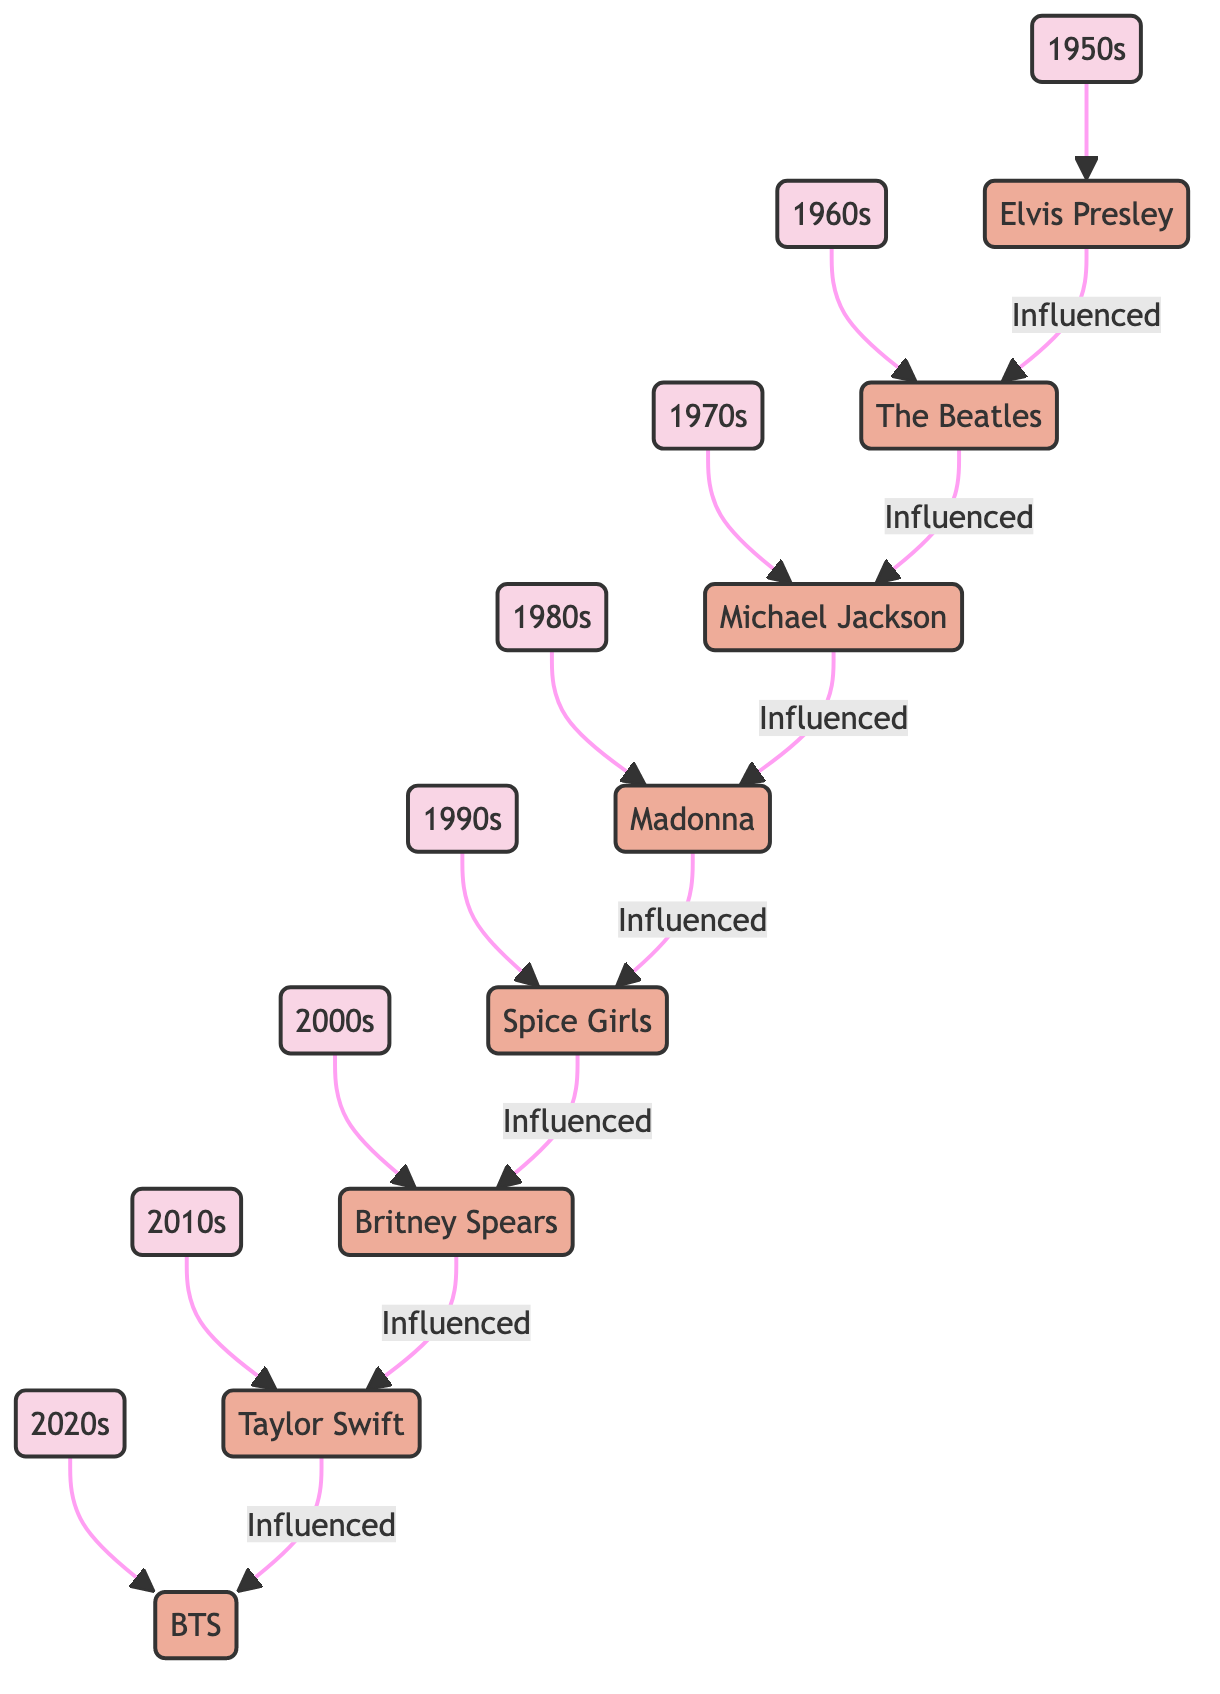What decade does Elvis Presley represent in the diagram? The node labeled "Elvis Presley" is connected to the node labeled "1950s." Hence, the decade he represents is the 1950s.
Answer: 1950s How many influential artists are listed in the diagram? The diagram contains eight artists, each connected to a specific era, all of whom are noted as "Influential Artist" in the connections.
Answer: 8 Which artist is directly influenced by Madonna? The edge labeled "Influenced" leads from the node "Madonna" to the node "Spice Girls," indicating that Spice Girls are directly influenced by Madonna.
Answer: Spice Girls What is the relationship between the 2010s and Taylor Swift in the diagram? The node "2010s" points to the node "Taylor Swift" labeled "Influential Artist," showing that Taylor Swift represents and is notable in the 2010s era of pop music.
Answer: Influential Artist Who influenced Taylor Swift according to the diagram? The edge labeled "Influenced" leads from the node "Taylor Swift" to the node "BTS," which indicates that BTS is the artist influenced by Taylor Swift.
Answer: BTS Which decade saw the emergence of boy bands and girl groups? The "1990s" node is explicitly described with the emergence of boy bands and girl groups, as reflected in its definition within the diagram.
Answer: 1990s How does Michael Jackson fit into the evolution of pop music as shown in the diagram? Michael Jackson is connected to the "1970s" era as a representative artist and also holds a directional connection as being influenced by "The Beatles," demonstrating his key role in this evolution sequence.
Answer: 1970s Which artist connects the 1980s to the 1990s? Madonna, who is connected to the 1980s as an influential artist and has a directed edge labeled "Influenced" to "Spice Girls," connects these two decades through her influence.
Answer: Madonna What genre blending is characteristic of the 2020s? The node labeled "2020s" describes this era as characterized by "genre-blending," indicating a significant trend in the current music landscape.
Answer: Genre-blending 